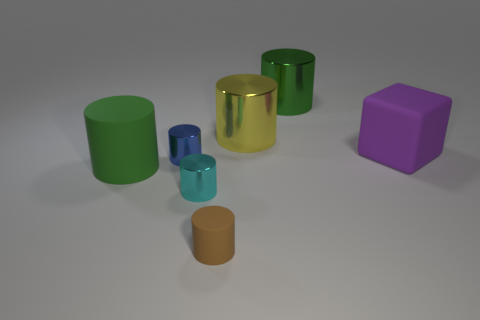How many objects are in front of the metal thing that is to the right of the big yellow cylinder?
Ensure brevity in your answer.  6. There is another large cylinder that is the same color as the big matte cylinder; what material is it?
Your answer should be compact. Metal. What number of other things are the same color as the large matte cube?
Provide a short and direct response. 0. What is the color of the tiny shiny thing in front of the large matte thing that is on the left side of the brown thing?
Make the answer very short. Cyan. Is there a small rubber cylinder that has the same color as the cube?
Give a very brief answer. No. How many rubber things are green objects or cubes?
Make the answer very short. 2. Is there a blue thing that has the same material as the purple thing?
Provide a short and direct response. No. What number of things are both on the right side of the tiny cyan object and in front of the yellow thing?
Give a very brief answer. 2. Are there fewer small brown cylinders that are on the left side of the tiny brown thing than big purple cubes to the left of the yellow cylinder?
Ensure brevity in your answer.  No. Is the green metal thing the same shape as the tiny brown matte object?
Offer a terse response. Yes. 